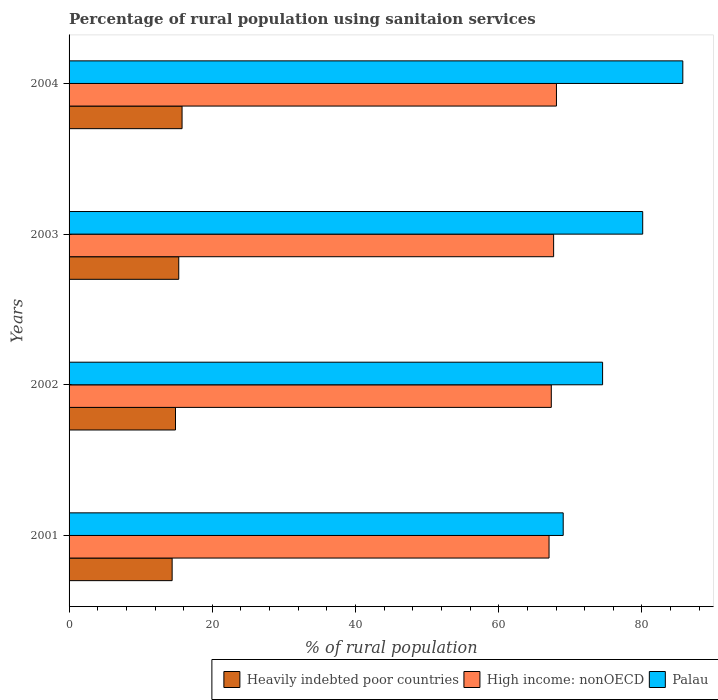How many different coloured bars are there?
Ensure brevity in your answer.  3. What is the label of the 2nd group of bars from the top?
Ensure brevity in your answer.  2003. What is the percentage of rural population using sanitaion services in Palau in 2004?
Make the answer very short. 85.7. Across all years, what is the maximum percentage of rural population using sanitaion services in Heavily indebted poor countries?
Your answer should be compact. 15.78. Across all years, what is the minimum percentage of rural population using sanitaion services in High income: nonOECD?
Offer a very short reply. 67.02. In which year was the percentage of rural population using sanitaion services in High income: nonOECD maximum?
Your answer should be very brief. 2004. In which year was the percentage of rural population using sanitaion services in Heavily indebted poor countries minimum?
Offer a terse response. 2001. What is the total percentage of rural population using sanitaion services in Heavily indebted poor countries in the graph?
Provide a short and direct response. 60.35. What is the difference between the percentage of rural population using sanitaion services in High income: nonOECD in 2001 and that in 2003?
Your response must be concise. -0.64. What is the difference between the percentage of rural population using sanitaion services in Palau in 2001 and the percentage of rural population using sanitaion services in High income: nonOECD in 2003?
Your answer should be very brief. 1.34. What is the average percentage of rural population using sanitaion services in Heavily indebted poor countries per year?
Your answer should be compact. 15.09. In the year 2002, what is the difference between the percentage of rural population using sanitaion services in Heavily indebted poor countries and percentage of rural population using sanitaion services in Palau?
Make the answer very short. -59.64. In how many years, is the percentage of rural population using sanitaion services in Heavily indebted poor countries greater than 76 %?
Ensure brevity in your answer.  0. What is the ratio of the percentage of rural population using sanitaion services in Palau in 2001 to that in 2003?
Give a very brief answer. 0.86. Is the percentage of rural population using sanitaion services in Palau in 2001 less than that in 2004?
Provide a short and direct response. Yes. Is the difference between the percentage of rural population using sanitaion services in Heavily indebted poor countries in 2001 and 2003 greater than the difference between the percentage of rural population using sanitaion services in Palau in 2001 and 2003?
Your answer should be very brief. Yes. What is the difference between the highest and the second highest percentage of rural population using sanitaion services in High income: nonOECD?
Ensure brevity in your answer.  0.4. What is the difference between the highest and the lowest percentage of rural population using sanitaion services in Palau?
Your answer should be very brief. 16.7. What does the 1st bar from the top in 2002 represents?
Your response must be concise. Palau. What does the 1st bar from the bottom in 2003 represents?
Your answer should be very brief. Heavily indebted poor countries. Is it the case that in every year, the sum of the percentage of rural population using sanitaion services in Heavily indebted poor countries and percentage of rural population using sanitaion services in Palau is greater than the percentage of rural population using sanitaion services in High income: nonOECD?
Your answer should be very brief. Yes. How many bars are there?
Your response must be concise. 12. Are all the bars in the graph horizontal?
Provide a succinct answer. Yes. How many years are there in the graph?
Make the answer very short. 4. Are the values on the major ticks of X-axis written in scientific E-notation?
Keep it short and to the point. No. How many legend labels are there?
Offer a very short reply. 3. How are the legend labels stacked?
Make the answer very short. Horizontal. What is the title of the graph?
Give a very brief answer. Percentage of rural population using sanitaion services. Does "Low income" appear as one of the legend labels in the graph?
Provide a short and direct response. No. What is the label or title of the X-axis?
Offer a terse response. % of rural population. What is the % of rural population in Heavily indebted poor countries in 2001?
Make the answer very short. 14.39. What is the % of rural population in High income: nonOECD in 2001?
Your answer should be compact. 67.02. What is the % of rural population in Heavily indebted poor countries in 2002?
Your answer should be compact. 14.86. What is the % of rural population in High income: nonOECD in 2002?
Give a very brief answer. 67.34. What is the % of rural population in Palau in 2002?
Give a very brief answer. 74.5. What is the % of rural population in Heavily indebted poor countries in 2003?
Keep it short and to the point. 15.32. What is the % of rural population of High income: nonOECD in 2003?
Provide a succinct answer. 67.66. What is the % of rural population in Palau in 2003?
Keep it short and to the point. 80.1. What is the % of rural population of Heavily indebted poor countries in 2004?
Your answer should be very brief. 15.78. What is the % of rural population in High income: nonOECD in 2004?
Provide a short and direct response. 68.06. What is the % of rural population of Palau in 2004?
Make the answer very short. 85.7. Across all years, what is the maximum % of rural population in Heavily indebted poor countries?
Keep it short and to the point. 15.78. Across all years, what is the maximum % of rural population in High income: nonOECD?
Make the answer very short. 68.06. Across all years, what is the maximum % of rural population in Palau?
Provide a short and direct response. 85.7. Across all years, what is the minimum % of rural population in Heavily indebted poor countries?
Your response must be concise. 14.39. Across all years, what is the minimum % of rural population in High income: nonOECD?
Your response must be concise. 67.02. What is the total % of rural population in Heavily indebted poor countries in the graph?
Ensure brevity in your answer.  60.35. What is the total % of rural population of High income: nonOECD in the graph?
Provide a short and direct response. 270.08. What is the total % of rural population in Palau in the graph?
Keep it short and to the point. 309.3. What is the difference between the % of rural population of Heavily indebted poor countries in 2001 and that in 2002?
Give a very brief answer. -0.47. What is the difference between the % of rural population of High income: nonOECD in 2001 and that in 2002?
Keep it short and to the point. -0.31. What is the difference between the % of rural population in Palau in 2001 and that in 2002?
Offer a very short reply. -5.5. What is the difference between the % of rural population in Heavily indebted poor countries in 2001 and that in 2003?
Offer a terse response. -0.92. What is the difference between the % of rural population of High income: nonOECD in 2001 and that in 2003?
Ensure brevity in your answer.  -0.64. What is the difference between the % of rural population of Heavily indebted poor countries in 2001 and that in 2004?
Your response must be concise. -1.39. What is the difference between the % of rural population of High income: nonOECD in 2001 and that in 2004?
Offer a very short reply. -1.03. What is the difference between the % of rural population in Palau in 2001 and that in 2004?
Your answer should be compact. -16.7. What is the difference between the % of rural population in Heavily indebted poor countries in 2002 and that in 2003?
Make the answer very short. -0.45. What is the difference between the % of rural population in High income: nonOECD in 2002 and that in 2003?
Offer a terse response. -0.32. What is the difference between the % of rural population of Heavily indebted poor countries in 2002 and that in 2004?
Provide a short and direct response. -0.92. What is the difference between the % of rural population in High income: nonOECD in 2002 and that in 2004?
Offer a terse response. -0.72. What is the difference between the % of rural population of Palau in 2002 and that in 2004?
Your response must be concise. -11.2. What is the difference between the % of rural population in Heavily indebted poor countries in 2003 and that in 2004?
Your response must be concise. -0.46. What is the difference between the % of rural population of High income: nonOECD in 2003 and that in 2004?
Offer a terse response. -0.4. What is the difference between the % of rural population in Palau in 2003 and that in 2004?
Your response must be concise. -5.6. What is the difference between the % of rural population of Heavily indebted poor countries in 2001 and the % of rural population of High income: nonOECD in 2002?
Provide a succinct answer. -52.95. What is the difference between the % of rural population of Heavily indebted poor countries in 2001 and the % of rural population of Palau in 2002?
Your answer should be very brief. -60.11. What is the difference between the % of rural population of High income: nonOECD in 2001 and the % of rural population of Palau in 2002?
Keep it short and to the point. -7.48. What is the difference between the % of rural population in Heavily indebted poor countries in 2001 and the % of rural population in High income: nonOECD in 2003?
Offer a very short reply. -53.27. What is the difference between the % of rural population in Heavily indebted poor countries in 2001 and the % of rural population in Palau in 2003?
Provide a succinct answer. -65.71. What is the difference between the % of rural population in High income: nonOECD in 2001 and the % of rural population in Palau in 2003?
Provide a succinct answer. -13.08. What is the difference between the % of rural population of Heavily indebted poor countries in 2001 and the % of rural population of High income: nonOECD in 2004?
Provide a succinct answer. -53.67. What is the difference between the % of rural population in Heavily indebted poor countries in 2001 and the % of rural population in Palau in 2004?
Your response must be concise. -71.31. What is the difference between the % of rural population of High income: nonOECD in 2001 and the % of rural population of Palau in 2004?
Your answer should be compact. -18.68. What is the difference between the % of rural population of Heavily indebted poor countries in 2002 and the % of rural population of High income: nonOECD in 2003?
Ensure brevity in your answer.  -52.8. What is the difference between the % of rural population of Heavily indebted poor countries in 2002 and the % of rural population of Palau in 2003?
Your answer should be very brief. -65.24. What is the difference between the % of rural population of High income: nonOECD in 2002 and the % of rural population of Palau in 2003?
Provide a succinct answer. -12.76. What is the difference between the % of rural population in Heavily indebted poor countries in 2002 and the % of rural population in High income: nonOECD in 2004?
Offer a very short reply. -53.2. What is the difference between the % of rural population of Heavily indebted poor countries in 2002 and the % of rural population of Palau in 2004?
Offer a terse response. -70.84. What is the difference between the % of rural population in High income: nonOECD in 2002 and the % of rural population in Palau in 2004?
Offer a terse response. -18.36. What is the difference between the % of rural population of Heavily indebted poor countries in 2003 and the % of rural population of High income: nonOECD in 2004?
Your answer should be compact. -52.74. What is the difference between the % of rural population of Heavily indebted poor countries in 2003 and the % of rural population of Palau in 2004?
Offer a very short reply. -70.38. What is the difference between the % of rural population in High income: nonOECD in 2003 and the % of rural population in Palau in 2004?
Keep it short and to the point. -18.04. What is the average % of rural population of Heavily indebted poor countries per year?
Keep it short and to the point. 15.09. What is the average % of rural population in High income: nonOECD per year?
Your response must be concise. 67.52. What is the average % of rural population of Palau per year?
Provide a short and direct response. 77.33. In the year 2001, what is the difference between the % of rural population in Heavily indebted poor countries and % of rural population in High income: nonOECD?
Offer a very short reply. -52.63. In the year 2001, what is the difference between the % of rural population in Heavily indebted poor countries and % of rural population in Palau?
Offer a very short reply. -54.61. In the year 2001, what is the difference between the % of rural population in High income: nonOECD and % of rural population in Palau?
Provide a short and direct response. -1.98. In the year 2002, what is the difference between the % of rural population of Heavily indebted poor countries and % of rural population of High income: nonOECD?
Your answer should be very brief. -52.48. In the year 2002, what is the difference between the % of rural population of Heavily indebted poor countries and % of rural population of Palau?
Ensure brevity in your answer.  -59.64. In the year 2002, what is the difference between the % of rural population in High income: nonOECD and % of rural population in Palau?
Your answer should be compact. -7.16. In the year 2003, what is the difference between the % of rural population in Heavily indebted poor countries and % of rural population in High income: nonOECD?
Provide a succinct answer. -52.34. In the year 2003, what is the difference between the % of rural population of Heavily indebted poor countries and % of rural population of Palau?
Give a very brief answer. -64.78. In the year 2003, what is the difference between the % of rural population of High income: nonOECD and % of rural population of Palau?
Keep it short and to the point. -12.44. In the year 2004, what is the difference between the % of rural population in Heavily indebted poor countries and % of rural population in High income: nonOECD?
Provide a short and direct response. -52.28. In the year 2004, what is the difference between the % of rural population in Heavily indebted poor countries and % of rural population in Palau?
Make the answer very short. -69.92. In the year 2004, what is the difference between the % of rural population in High income: nonOECD and % of rural population in Palau?
Provide a short and direct response. -17.64. What is the ratio of the % of rural population of Heavily indebted poor countries in 2001 to that in 2002?
Make the answer very short. 0.97. What is the ratio of the % of rural population of Palau in 2001 to that in 2002?
Keep it short and to the point. 0.93. What is the ratio of the % of rural population of Heavily indebted poor countries in 2001 to that in 2003?
Your answer should be compact. 0.94. What is the ratio of the % of rural population in High income: nonOECD in 2001 to that in 2003?
Your response must be concise. 0.99. What is the ratio of the % of rural population in Palau in 2001 to that in 2003?
Your response must be concise. 0.86. What is the ratio of the % of rural population of Heavily indebted poor countries in 2001 to that in 2004?
Provide a succinct answer. 0.91. What is the ratio of the % of rural population of Palau in 2001 to that in 2004?
Your response must be concise. 0.81. What is the ratio of the % of rural population of Heavily indebted poor countries in 2002 to that in 2003?
Offer a very short reply. 0.97. What is the ratio of the % of rural population of Palau in 2002 to that in 2003?
Your answer should be compact. 0.93. What is the ratio of the % of rural population of Heavily indebted poor countries in 2002 to that in 2004?
Offer a terse response. 0.94. What is the ratio of the % of rural population in Palau in 2002 to that in 2004?
Your response must be concise. 0.87. What is the ratio of the % of rural population of Heavily indebted poor countries in 2003 to that in 2004?
Provide a short and direct response. 0.97. What is the ratio of the % of rural population of Palau in 2003 to that in 2004?
Make the answer very short. 0.93. What is the difference between the highest and the second highest % of rural population of Heavily indebted poor countries?
Give a very brief answer. 0.46. What is the difference between the highest and the second highest % of rural population of High income: nonOECD?
Ensure brevity in your answer.  0.4. What is the difference between the highest and the lowest % of rural population of Heavily indebted poor countries?
Give a very brief answer. 1.39. What is the difference between the highest and the lowest % of rural population in High income: nonOECD?
Your response must be concise. 1.03. What is the difference between the highest and the lowest % of rural population in Palau?
Provide a short and direct response. 16.7. 